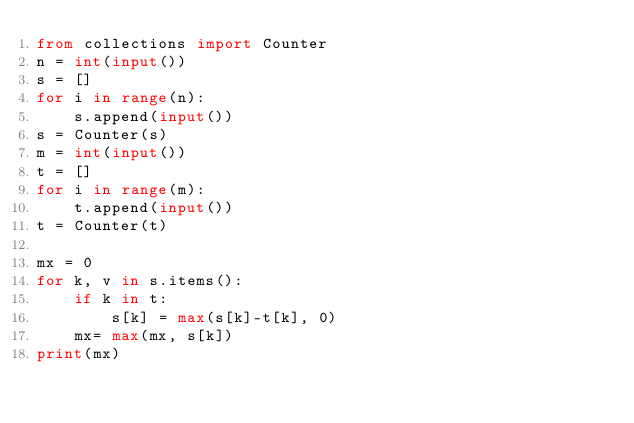Convert code to text. <code><loc_0><loc_0><loc_500><loc_500><_Python_>from collections import Counter
n = int(input())
s = []
for i in range(n):
    s.append(input())
s = Counter(s)
m = int(input())
t = []
for i in range(m):
    t.append(input())
t = Counter(t)

mx = 0
for k, v in s.items():
    if k in t:
        s[k] = max(s[k]-t[k], 0)
    mx= max(mx, s[k])
print(mx)</code> 